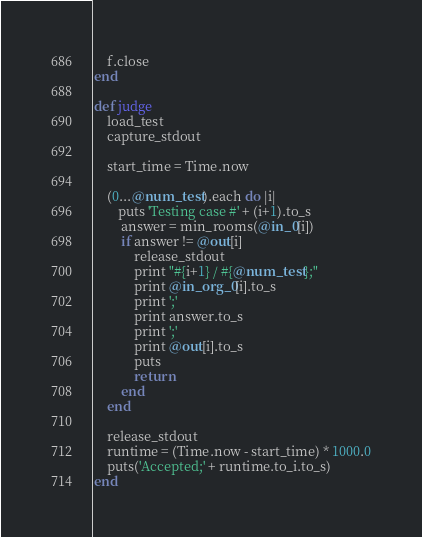<code> <loc_0><loc_0><loc_500><loc_500><_Ruby_>    f.close
end

def judge
    load_test
    capture_stdout

    start_time = Time.now

    (0...@num_test).each do |i|
       puts 'Testing case #' + (i+1).to_s
        answer = min_rooms(@in_0[i]) 
        if answer != @out[i]
            release_stdout
            print "#{i+1} / #{@num_test};"
            print @in_org_0[i].to_s
            print ';'
            print answer.to_s
            print ';'
            print @out[i].to_s
            puts
            return
        end
    end

    release_stdout
    runtime = (Time.now - start_time) * 1000.0
    puts('Accepted;' + runtime.to_i.to_s)
end
</code> 